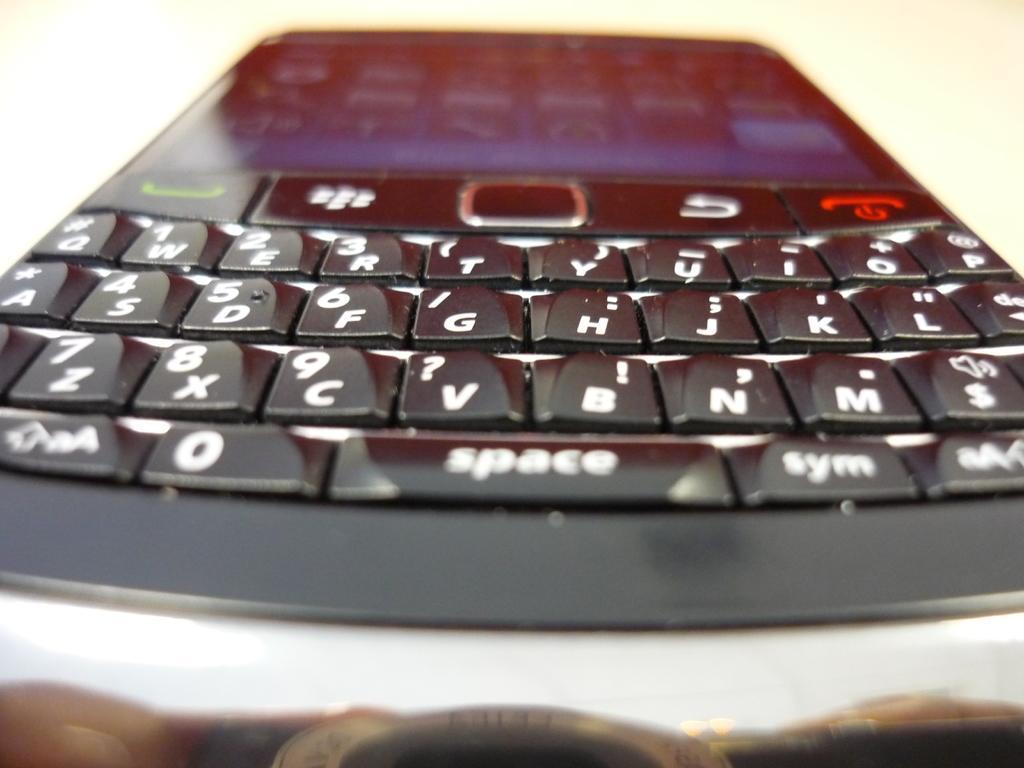Please provide a concise description of this image. In this image I can see a mobile phone and keypad. Background is white in color. 